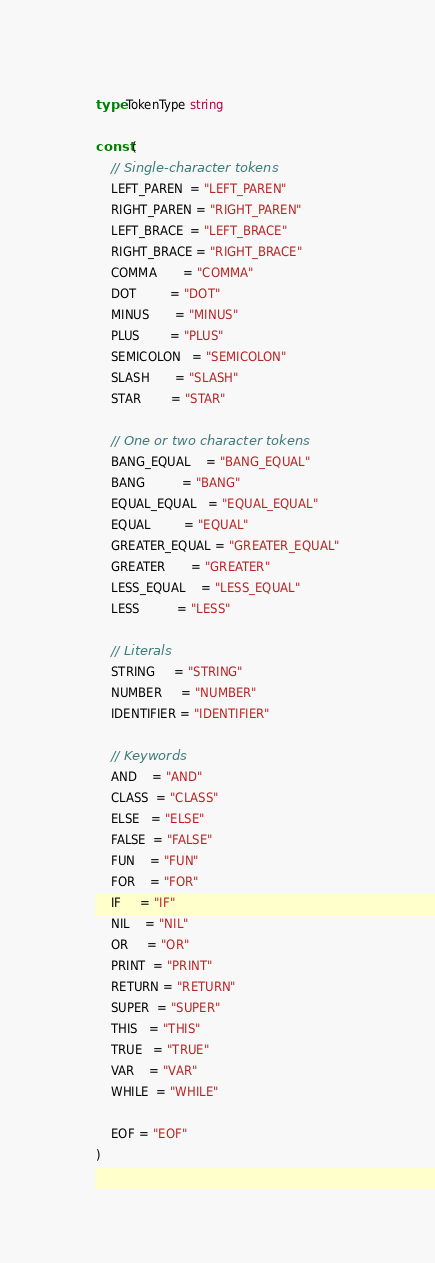Convert code to text. <code><loc_0><loc_0><loc_500><loc_500><_Go_>
type TokenType string

const (
	// Single-character tokens
	LEFT_PAREN  = "LEFT_PAREN"
	RIGHT_PAREN = "RIGHT_PAREN"
	LEFT_BRACE  = "LEFT_BRACE"
	RIGHT_BRACE = "RIGHT_BRACE"
	COMMA       = "COMMA"
	DOT         = "DOT"
	MINUS       = "MINUS"
	PLUS        = "PLUS"
	SEMICOLON   = "SEMICOLON"
	SLASH       = "SLASH"
	STAR        = "STAR"

	// One or two character tokens
	BANG_EQUAL    = "BANG_EQUAL"
	BANG          = "BANG"
	EQUAL_EQUAL   = "EQUAL_EQUAL"
	EQUAL         = "EQUAL"
	GREATER_EQUAL = "GREATER_EQUAL"
	GREATER       = "GREATER"
	LESS_EQUAL    = "LESS_EQUAL"
	LESS          = "LESS"

	// Literals
	STRING     = "STRING"
	NUMBER     = "NUMBER"
	IDENTIFIER = "IDENTIFIER"

	// Keywords
	AND    = "AND"
	CLASS  = "CLASS"
	ELSE   = "ELSE"
	FALSE  = "FALSE"
	FUN    = "FUN"
	FOR    = "FOR"
	IF     = "IF"
	NIL    = "NIL"
	OR     = "OR"
	PRINT  = "PRINT"
	RETURN = "RETURN"
	SUPER  = "SUPER"
	THIS   = "THIS"
	TRUE   = "TRUE"
	VAR    = "VAR"
	WHILE  = "WHILE"

	EOF = "EOF"
)
</code> 